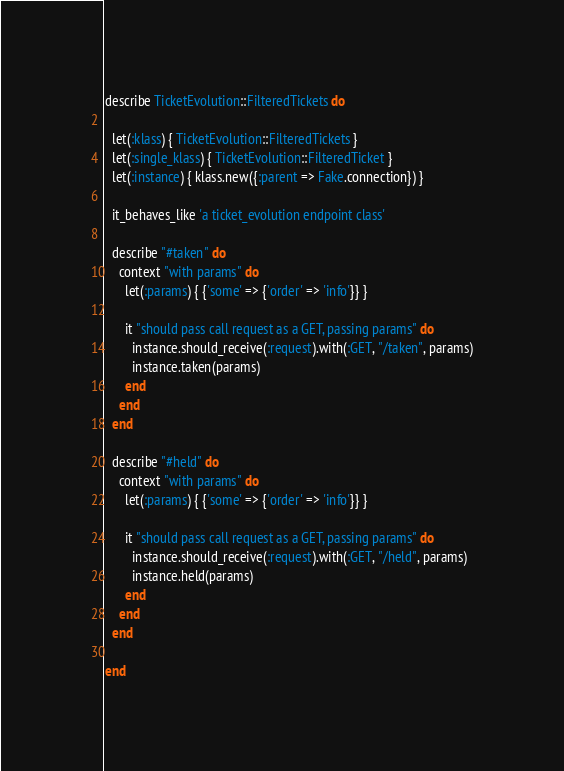Convert code to text. <code><loc_0><loc_0><loc_500><loc_500><_Ruby_>describe TicketEvolution::FilteredTickets do

  let(:klass) { TicketEvolution::FilteredTickets }
  let(:single_klass) { TicketEvolution::FilteredTicket }
  let(:instance) { klass.new({:parent => Fake.connection}) }

  it_behaves_like 'a ticket_evolution endpoint class'

  describe "#taken" do
    context "with params" do
      let(:params) { {'some' => {'order' => 'info'}} }

      it "should pass call request as a GET, passing params" do
        instance.should_receive(:request).with(:GET, "/taken", params)
        instance.taken(params)
      end
    end
  end

  describe "#held" do
    context "with params" do
      let(:params) { {'some' => {'order' => 'info'}} }

      it "should pass call request as a GET, passing params" do
        instance.should_receive(:request).with(:GET, "/held", params)
        instance.held(params)
      end
    end
  end

end</code> 